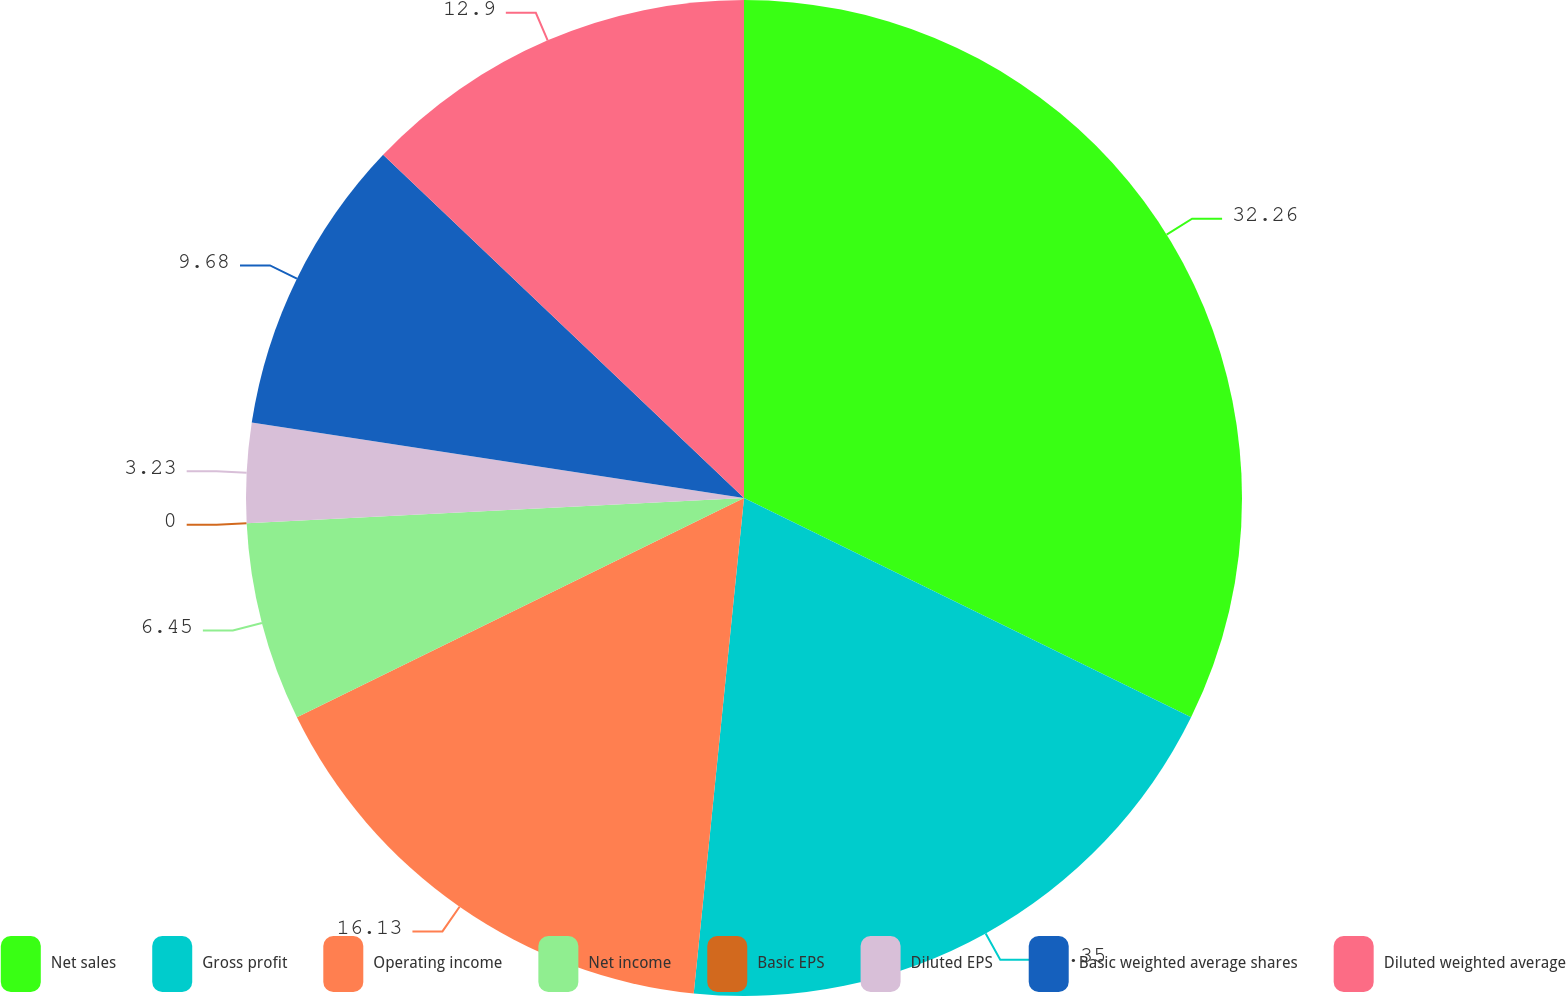Convert chart. <chart><loc_0><loc_0><loc_500><loc_500><pie_chart><fcel>Net sales<fcel>Gross profit<fcel>Operating income<fcel>Net income<fcel>Basic EPS<fcel>Diluted EPS<fcel>Basic weighted average shares<fcel>Diluted weighted average<nl><fcel>32.26%<fcel>19.35%<fcel>16.13%<fcel>6.45%<fcel>0.0%<fcel>3.23%<fcel>9.68%<fcel>12.9%<nl></chart> 